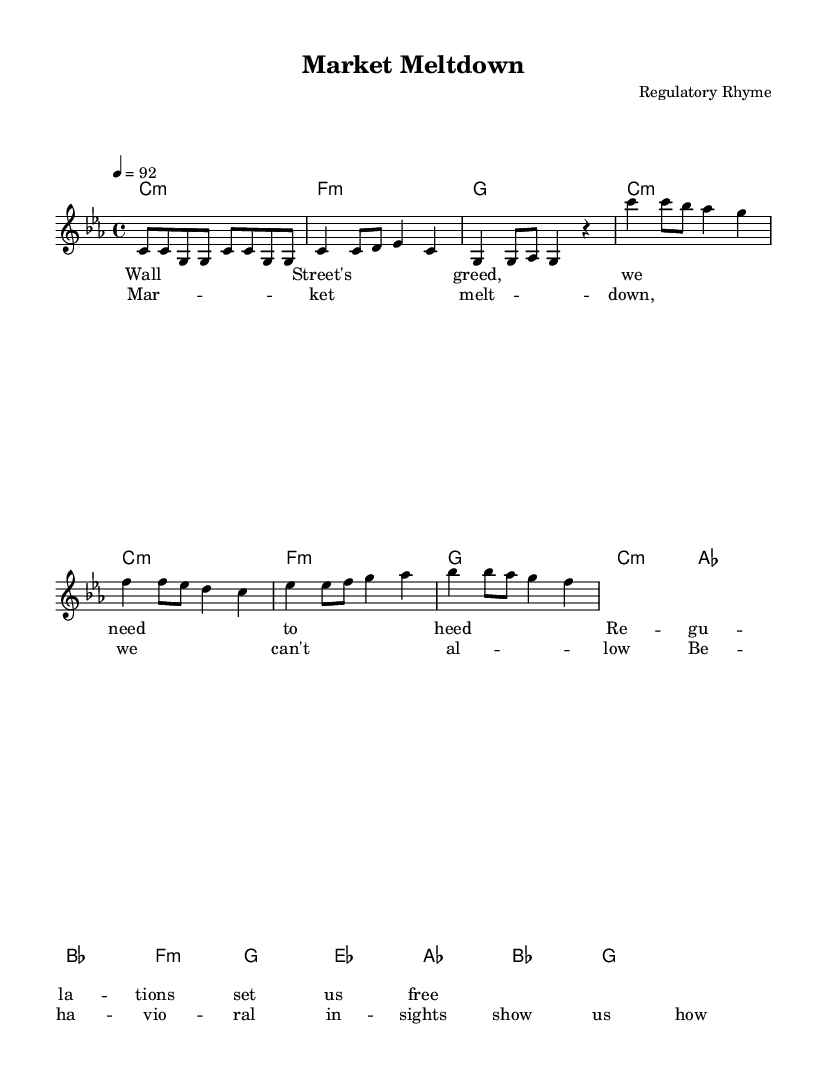What is the key signature of this music? The key signature is C minor, which has three flat notes (B flat, E flat, and A flat). This can be identified at the beginning of the sheet music where the key signature is indicated.
Answer: C minor What is the time signature of this music? The time signature is 4/4, meaning there are four beats in each measure and the quarter note gets one beat. This is evident in the notation at the beginning of the score.
Answer: 4/4 What is the tempo marking for this piece? The tempo marking is 92 beats per minute. This indicates how fast the music should be played, as noted by the "4 = 92" designation.
Answer: 92 How many measures are in the verse section? The verse contains 4 measures, which can be counted by looking at the grouping of musical notes and bars labeled in the verse section.
Answer: 4 Which part of the music has the lyrics "Market meltdown, we can't allow"? These lyrics are found in the chorus section, as identified by the location of these words under the corresponding measures after identifying the song structure.
Answer: Chorus What type of musical phrases are used in rap verses? The song contains repetitive lyrical phrasing, which is common in rap music to create rhythm and flow. The structure of the melody and lyrics suggests a focus on rhythmic delivery rather than melodic variety.
Answer: Repetitive What is the harmonic structure used in this music? The harmonic structure follows a minor chord progression, reflecting a darker tone typical for the themes discussed in politically charged rap. This progression can be traced through the chord changes noted in the harmonies section.
Answer: Minor chord progression 